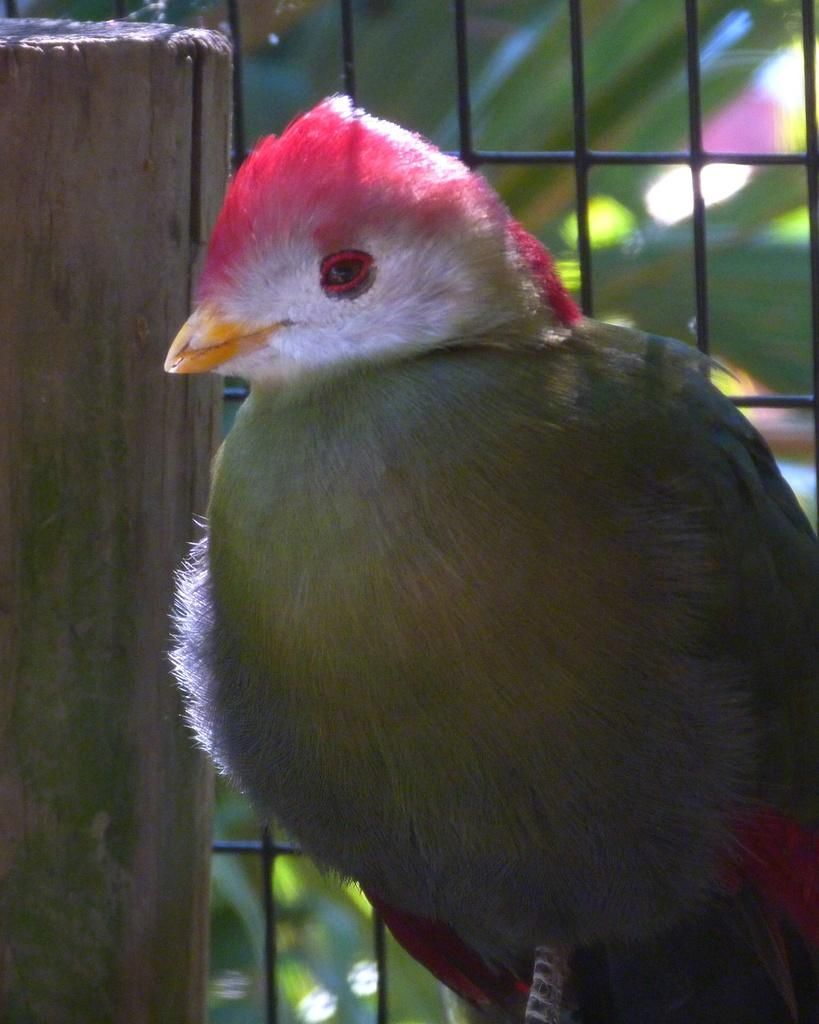What is the main subject in the middle of the image? There is a bird in the middle of the image. What can be seen on the left side of the image? There is a wood on the left side of the image. What type of material is visible in the background of the image? There are metal grills in the background of the image. What color is predominant in the background of the image? The background has a green color. What type of horn can be heard in the image? There is no horn present in the image, and therefore no sound can be heard. 